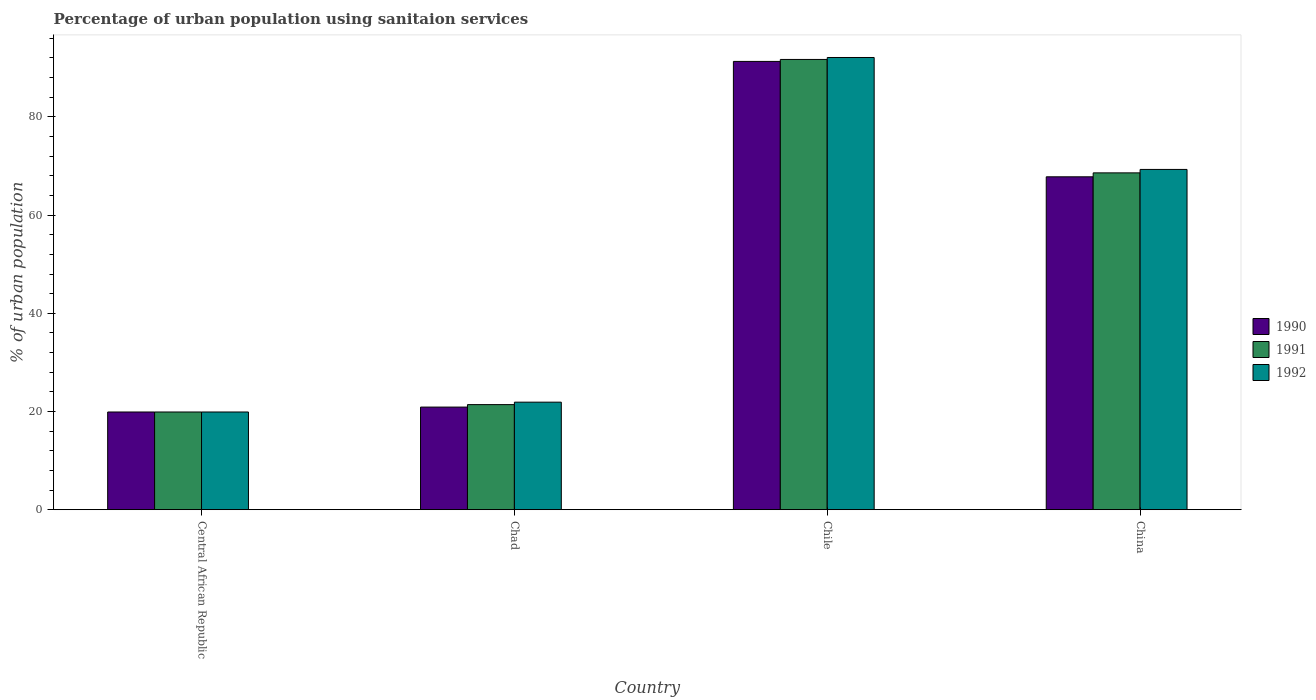How many different coloured bars are there?
Provide a short and direct response. 3. Are the number of bars on each tick of the X-axis equal?
Ensure brevity in your answer.  Yes. How many bars are there on the 2nd tick from the right?
Ensure brevity in your answer.  3. What is the label of the 3rd group of bars from the left?
Offer a terse response. Chile. Across all countries, what is the maximum percentage of urban population using sanitaion services in 1991?
Make the answer very short. 91.7. In which country was the percentage of urban population using sanitaion services in 1990 maximum?
Your response must be concise. Chile. In which country was the percentage of urban population using sanitaion services in 1992 minimum?
Give a very brief answer. Central African Republic. What is the total percentage of urban population using sanitaion services in 1991 in the graph?
Ensure brevity in your answer.  201.6. What is the difference between the percentage of urban population using sanitaion services in 1992 in Chad and that in Chile?
Your answer should be compact. -70.2. What is the difference between the percentage of urban population using sanitaion services in 1990 in Chad and the percentage of urban population using sanitaion services in 1992 in China?
Give a very brief answer. -48.4. What is the average percentage of urban population using sanitaion services in 1990 per country?
Keep it short and to the point. 49.97. What is the difference between the percentage of urban population using sanitaion services of/in 1992 and percentage of urban population using sanitaion services of/in 1991 in Chad?
Your answer should be compact. 0.5. What is the ratio of the percentage of urban population using sanitaion services in 1992 in Chile to that in China?
Offer a very short reply. 1.33. Is the difference between the percentage of urban population using sanitaion services in 1992 in Central African Republic and Chad greater than the difference between the percentage of urban population using sanitaion services in 1991 in Central African Republic and Chad?
Ensure brevity in your answer.  No. What is the difference between the highest and the second highest percentage of urban population using sanitaion services in 1991?
Provide a short and direct response. 23.1. What is the difference between the highest and the lowest percentage of urban population using sanitaion services in 1990?
Your answer should be very brief. 71.4. Does the graph contain grids?
Provide a succinct answer. No. Where does the legend appear in the graph?
Offer a very short reply. Center right. How many legend labels are there?
Your answer should be very brief. 3. What is the title of the graph?
Give a very brief answer. Percentage of urban population using sanitaion services. What is the label or title of the Y-axis?
Give a very brief answer. % of urban population. What is the % of urban population in 1991 in Central African Republic?
Your answer should be compact. 19.9. What is the % of urban population of 1990 in Chad?
Keep it short and to the point. 20.9. What is the % of urban population of 1991 in Chad?
Provide a short and direct response. 21.4. What is the % of urban population of 1992 in Chad?
Provide a succinct answer. 21.9. What is the % of urban population of 1990 in Chile?
Provide a succinct answer. 91.3. What is the % of urban population in 1991 in Chile?
Give a very brief answer. 91.7. What is the % of urban population of 1992 in Chile?
Provide a succinct answer. 92.1. What is the % of urban population of 1990 in China?
Offer a terse response. 67.8. What is the % of urban population of 1991 in China?
Your answer should be compact. 68.6. What is the % of urban population of 1992 in China?
Keep it short and to the point. 69.3. Across all countries, what is the maximum % of urban population in 1990?
Make the answer very short. 91.3. Across all countries, what is the maximum % of urban population in 1991?
Provide a short and direct response. 91.7. Across all countries, what is the maximum % of urban population in 1992?
Provide a short and direct response. 92.1. Across all countries, what is the minimum % of urban population in 1990?
Give a very brief answer. 19.9. Across all countries, what is the minimum % of urban population in 1991?
Provide a succinct answer. 19.9. What is the total % of urban population in 1990 in the graph?
Make the answer very short. 199.9. What is the total % of urban population in 1991 in the graph?
Offer a very short reply. 201.6. What is the total % of urban population in 1992 in the graph?
Your response must be concise. 203.2. What is the difference between the % of urban population in 1990 in Central African Republic and that in Chad?
Offer a terse response. -1. What is the difference between the % of urban population in 1991 in Central African Republic and that in Chad?
Provide a short and direct response. -1.5. What is the difference between the % of urban population in 1990 in Central African Republic and that in Chile?
Ensure brevity in your answer.  -71.4. What is the difference between the % of urban population in 1991 in Central African Republic and that in Chile?
Provide a succinct answer. -71.8. What is the difference between the % of urban population in 1992 in Central African Republic and that in Chile?
Ensure brevity in your answer.  -72.2. What is the difference between the % of urban population in 1990 in Central African Republic and that in China?
Ensure brevity in your answer.  -47.9. What is the difference between the % of urban population of 1991 in Central African Republic and that in China?
Make the answer very short. -48.7. What is the difference between the % of urban population in 1992 in Central African Republic and that in China?
Make the answer very short. -49.4. What is the difference between the % of urban population of 1990 in Chad and that in Chile?
Ensure brevity in your answer.  -70.4. What is the difference between the % of urban population of 1991 in Chad and that in Chile?
Your response must be concise. -70.3. What is the difference between the % of urban population in 1992 in Chad and that in Chile?
Make the answer very short. -70.2. What is the difference between the % of urban population of 1990 in Chad and that in China?
Ensure brevity in your answer.  -46.9. What is the difference between the % of urban population in 1991 in Chad and that in China?
Offer a terse response. -47.2. What is the difference between the % of urban population of 1992 in Chad and that in China?
Provide a short and direct response. -47.4. What is the difference between the % of urban population in 1991 in Chile and that in China?
Your response must be concise. 23.1. What is the difference between the % of urban population in 1992 in Chile and that in China?
Make the answer very short. 22.8. What is the difference between the % of urban population in 1991 in Central African Republic and the % of urban population in 1992 in Chad?
Provide a short and direct response. -2. What is the difference between the % of urban population in 1990 in Central African Republic and the % of urban population in 1991 in Chile?
Keep it short and to the point. -71.8. What is the difference between the % of urban population of 1990 in Central African Republic and the % of urban population of 1992 in Chile?
Your answer should be very brief. -72.2. What is the difference between the % of urban population in 1991 in Central African Republic and the % of urban population in 1992 in Chile?
Ensure brevity in your answer.  -72.2. What is the difference between the % of urban population in 1990 in Central African Republic and the % of urban population in 1991 in China?
Ensure brevity in your answer.  -48.7. What is the difference between the % of urban population of 1990 in Central African Republic and the % of urban population of 1992 in China?
Keep it short and to the point. -49.4. What is the difference between the % of urban population of 1991 in Central African Republic and the % of urban population of 1992 in China?
Your answer should be compact. -49.4. What is the difference between the % of urban population of 1990 in Chad and the % of urban population of 1991 in Chile?
Provide a short and direct response. -70.8. What is the difference between the % of urban population in 1990 in Chad and the % of urban population in 1992 in Chile?
Your answer should be very brief. -71.2. What is the difference between the % of urban population in 1991 in Chad and the % of urban population in 1992 in Chile?
Provide a short and direct response. -70.7. What is the difference between the % of urban population of 1990 in Chad and the % of urban population of 1991 in China?
Ensure brevity in your answer.  -47.7. What is the difference between the % of urban population of 1990 in Chad and the % of urban population of 1992 in China?
Make the answer very short. -48.4. What is the difference between the % of urban population of 1991 in Chad and the % of urban population of 1992 in China?
Offer a terse response. -47.9. What is the difference between the % of urban population of 1990 in Chile and the % of urban population of 1991 in China?
Give a very brief answer. 22.7. What is the difference between the % of urban population in 1990 in Chile and the % of urban population in 1992 in China?
Provide a short and direct response. 22. What is the difference between the % of urban population of 1991 in Chile and the % of urban population of 1992 in China?
Offer a terse response. 22.4. What is the average % of urban population in 1990 per country?
Provide a short and direct response. 49.98. What is the average % of urban population of 1991 per country?
Your response must be concise. 50.4. What is the average % of urban population of 1992 per country?
Your answer should be compact. 50.8. What is the difference between the % of urban population of 1990 and % of urban population of 1991 in Central African Republic?
Provide a succinct answer. 0. What is the difference between the % of urban population in 1990 and % of urban population in 1992 in Chile?
Your response must be concise. -0.8. What is the difference between the % of urban population of 1991 and % of urban population of 1992 in Chile?
Offer a terse response. -0.4. What is the difference between the % of urban population of 1990 and % of urban population of 1992 in China?
Make the answer very short. -1.5. What is the ratio of the % of urban population of 1990 in Central African Republic to that in Chad?
Your response must be concise. 0.95. What is the ratio of the % of urban population of 1991 in Central African Republic to that in Chad?
Keep it short and to the point. 0.93. What is the ratio of the % of urban population in 1992 in Central African Republic to that in Chad?
Offer a terse response. 0.91. What is the ratio of the % of urban population of 1990 in Central African Republic to that in Chile?
Offer a very short reply. 0.22. What is the ratio of the % of urban population in 1991 in Central African Republic to that in Chile?
Ensure brevity in your answer.  0.22. What is the ratio of the % of urban population of 1992 in Central African Republic to that in Chile?
Provide a short and direct response. 0.22. What is the ratio of the % of urban population of 1990 in Central African Republic to that in China?
Provide a short and direct response. 0.29. What is the ratio of the % of urban population of 1991 in Central African Republic to that in China?
Offer a very short reply. 0.29. What is the ratio of the % of urban population in 1992 in Central African Republic to that in China?
Ensure brevity in your answer.  0.29. What is the ratio of the % of urban population of 1990 in Chad to that in Chile?
Keep it short and to the point. 0.23. What is the ratio of the % of urban population of 1991 in Chad to that in Chile?
Offer a terse response. 0.23. What is the ratio of the % of urban population of 1992 in Chad to that in Chile?
Offer a terse response. 0.24. What is the ratio of the % of urban population of 1990 in Chad to that in China?
Provide a succinct answer. 0.31. What is the ratio of the % of urban population of 1991 in Chad to that in China?
Provide a succinct answer. 0.31. What is the ratio of the % of urban population of 1992 in Chad to that in China?
Provide a succinct answer. 0.32. What is the ratio of the % of urban population in 1990 in Chile to that in China?
Provide a succinct answer. 1.35. What is the ratio of the % of urban population in 1991 in Chile to that in China?
Your answer should be very brief. 1.34. What is the ratio of the % of urban population of 1992 in Chile to that in China?
Your answer should be compact. 1.33. What is the difference between the highest and the second highest % of urban population in 1990?
Offer a very short reply. 23.5. What is the difference between the highest and the second highest % of urban population in 1991?
Your answer should be compact. 23.1. What is the difference between the highest and the second highest % of urban population in 1992?
Give a very brief answer. 22.8. What is the difference between the highest and the lowest % of urban population in 1990?
Provide a short and direct response. 71.4. What is the difference between the highest and the lowest % of urban population of 1991?
Keep it short and to the point. 71.8. What is the difference between the highest and the lowest % of urban population in 1992?
Your response must be concise. 72.2. 